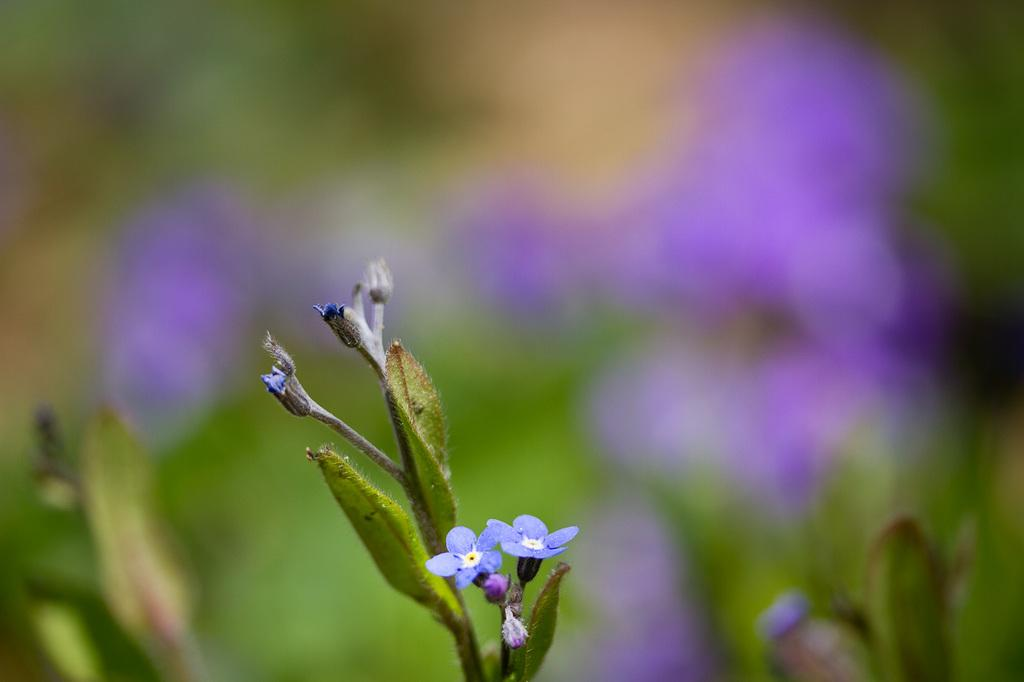What type of plant life can be seen in the image? There are leaves and flowers in the image. Can you describe the colors of the flowers? The colors of the flowers cannot be determined from the provided facts. Are there any other objects or subjects in the image besides the leaves and flowers? No additional information is provided about other objects or subjects in the image. How does the animal in the image help with the gardening process? There is no animal present in the image, so it cannot be determined how an animal might help with the gardening process. 